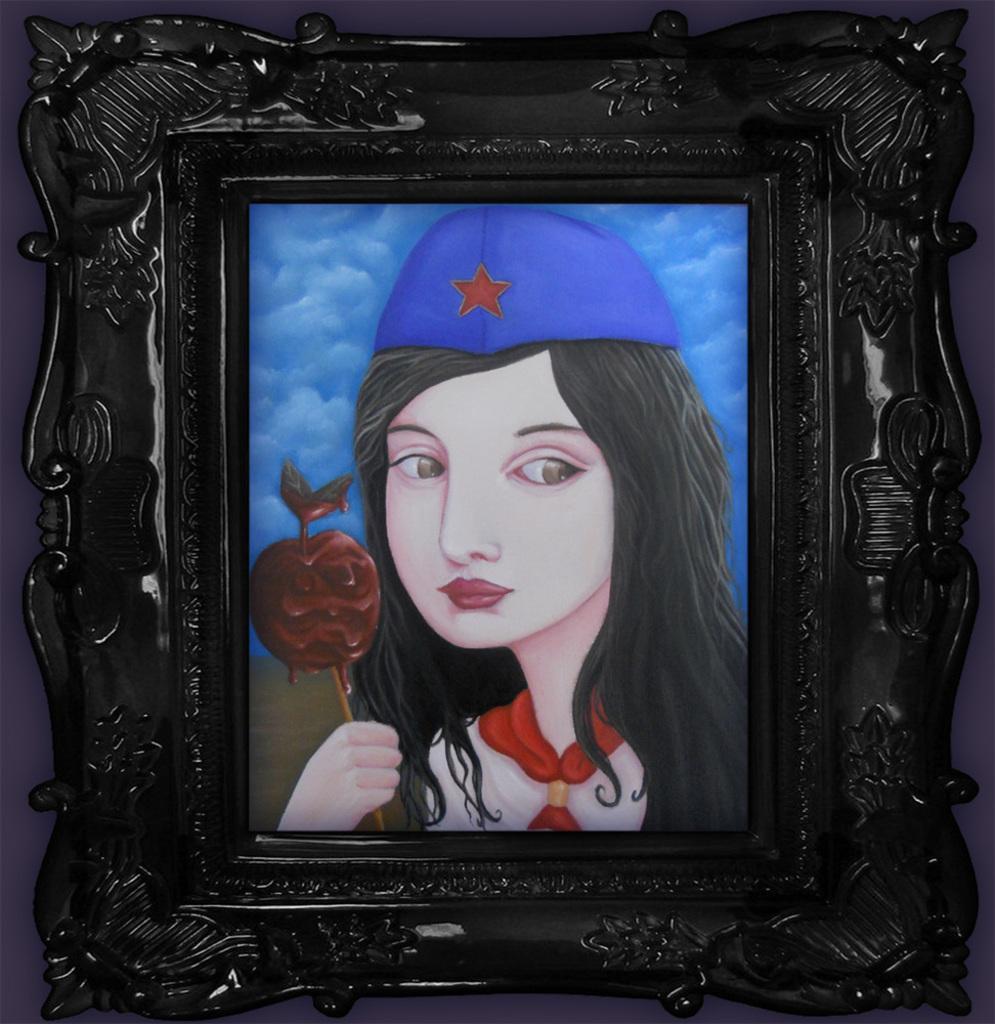How would you summarize this image in a sentence or two? This image consists of a frame in which we can see a painting of a woman. 